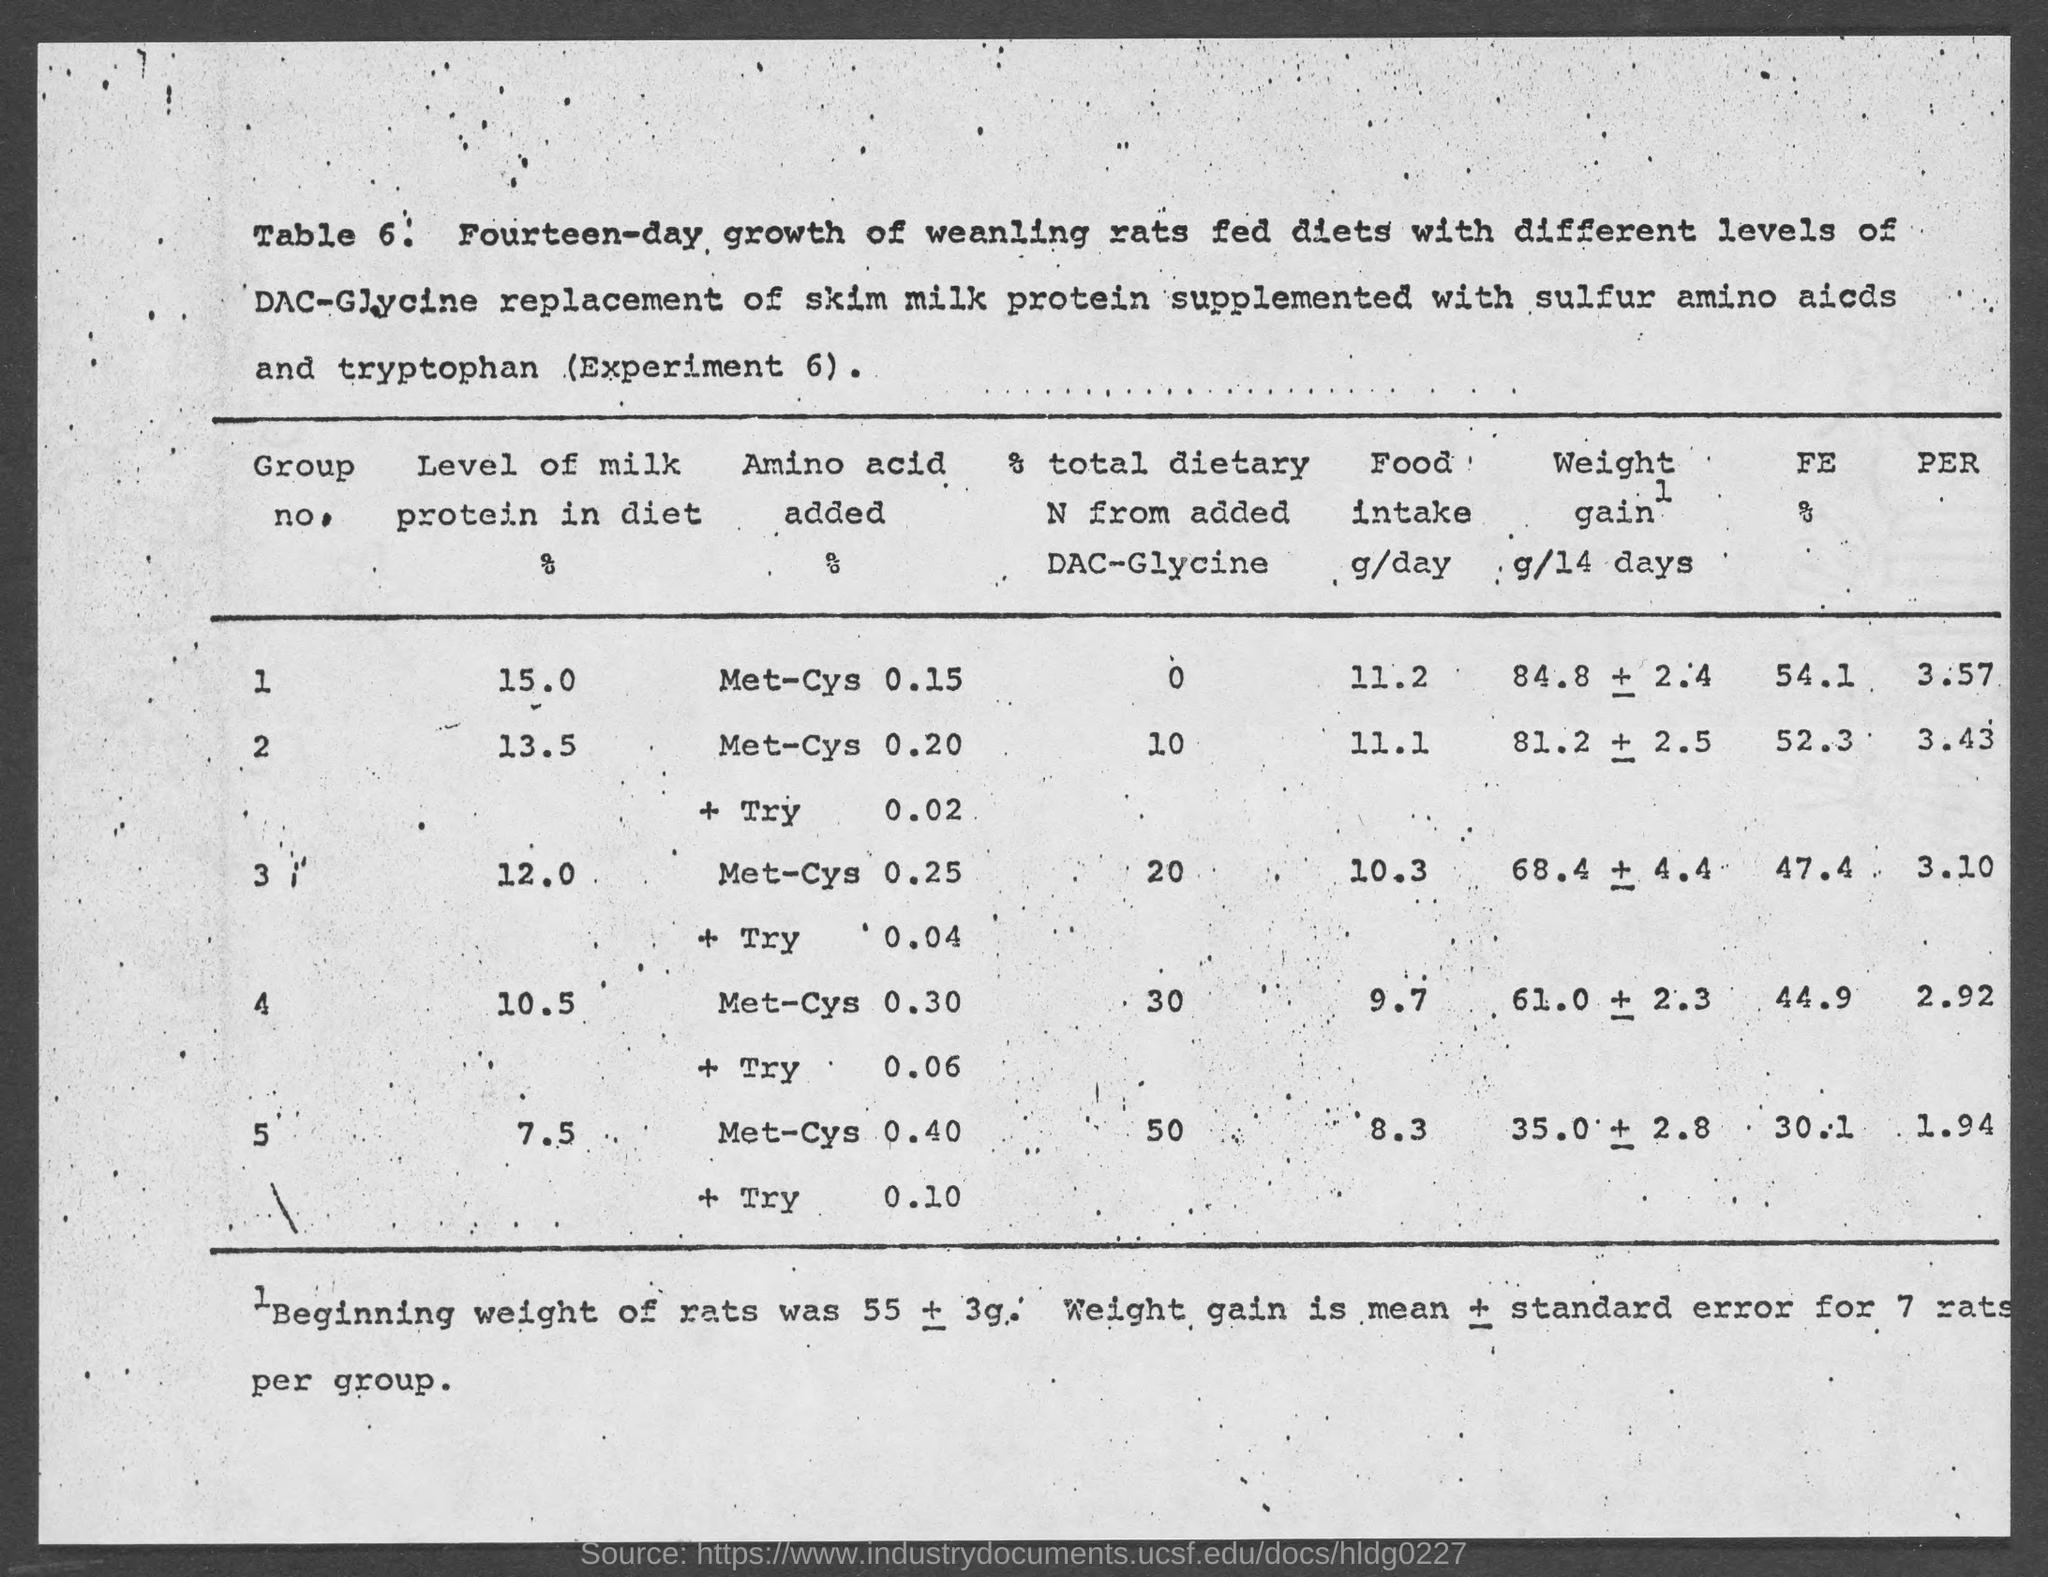What is the table number?
Your answer should be compact. 6. What is the level of milk protein in the diet in group 1?
Make the answer very short. 15.0. What is the level of milk protein in the diet in group 5?
Provide a short and direct response. 7.5. What is the level of milk protein in the diet in group 2?
Keep it short and to the point. 13.5. The level of milk protein in the diet is high in which group?
Your answer should be compact. 1. The level of milk protein in the diet is low in which group?
Ensure brevity in your answer.  5. 